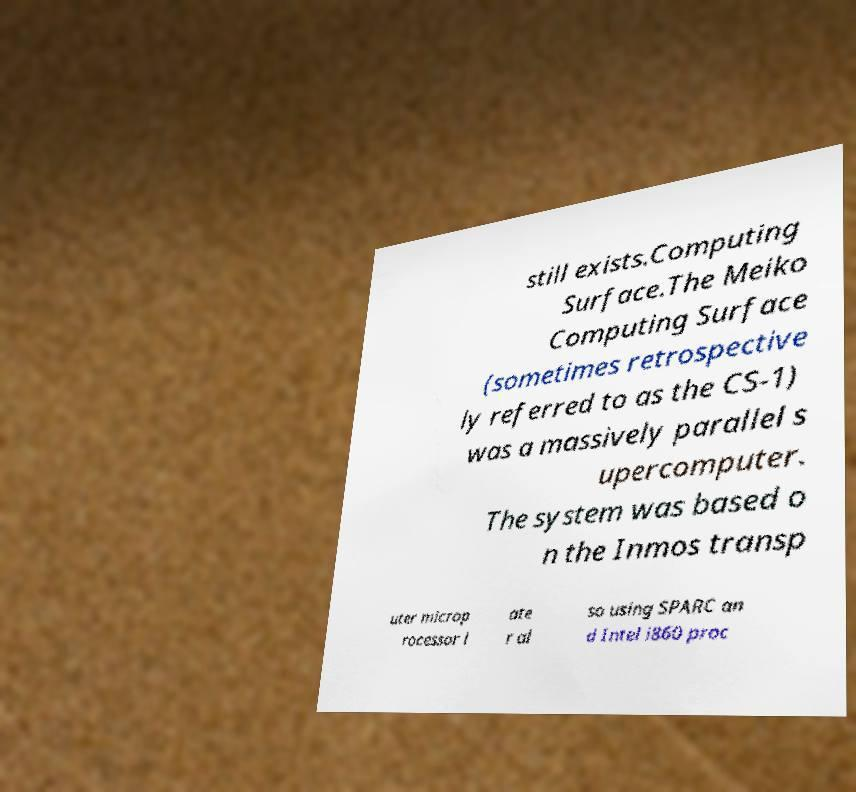Can you accurately transcribe the text from the provided image for me? still exists.Computing Surface.The Meiko Computing Surface (sometimes retrospective ly referred to as the CS-1) was a massively parallel s upercomputer. The system was based o n the Inmos transp uter microp rocessor l ate r al so using SPARC an d Intel i860 proc 